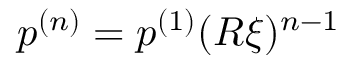Convert formula to latex. <formula><loc_0><loc_0><loc_500><loc_500>p ^ { ( n ) } = p ^ { ( 1 ) } ( R \xi ) ^ { n - 1 }</formula> 